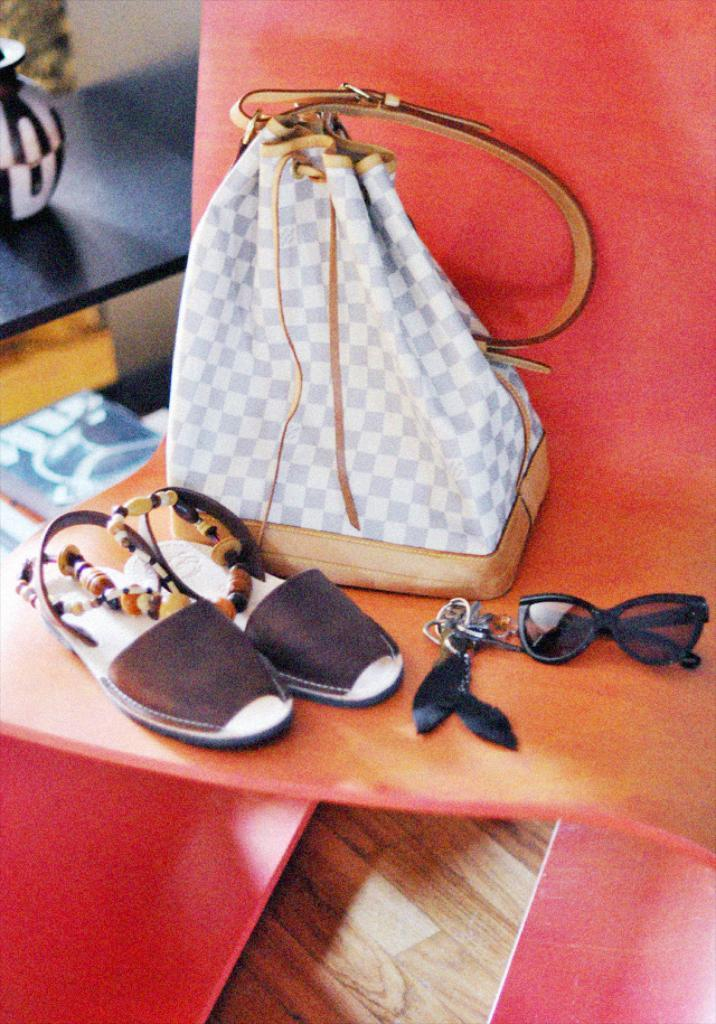What is placed on the chair in the image? There is a bag, footwear, keys, and glasses placed on the chair. Can you describe the items placed on the chair in more detail? The bag is likely a backpack or handbag, the footwear appears to be shoes, the keys are small and metallic, and the glasses are for vision correction. What might be the purpose of placing these items on the chair? Placing these items on the chair could be for temporary storage or to keep them within reach. How many tomatoes are visible on the chair in the image? There are no tomatoes visible on the chair in the image. What achievements have the keys unlocked in the image? The keys do not have any achievements associated with them in the image; they are simply objects used for unlocking doors or other items. 